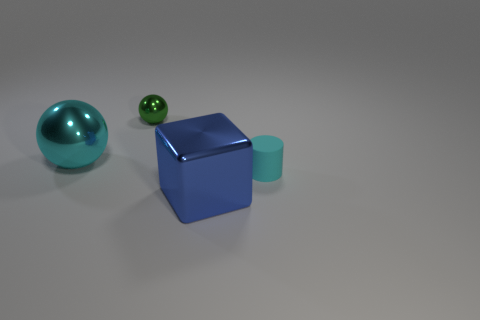What lighting conditions are present in the scene? The lighting in the scene is soft and diffuse, producing gentle shadows on one side of the objects, indicating a single light source that seems to come from the upper right side of the frame. Does the lighting affect the color perception of the objects? Yes, the lighting can affect color perception. However, in this image, the soft and uniform lighting allows the colors of the objects to appear consistent and true to their likely real-world appearance. 